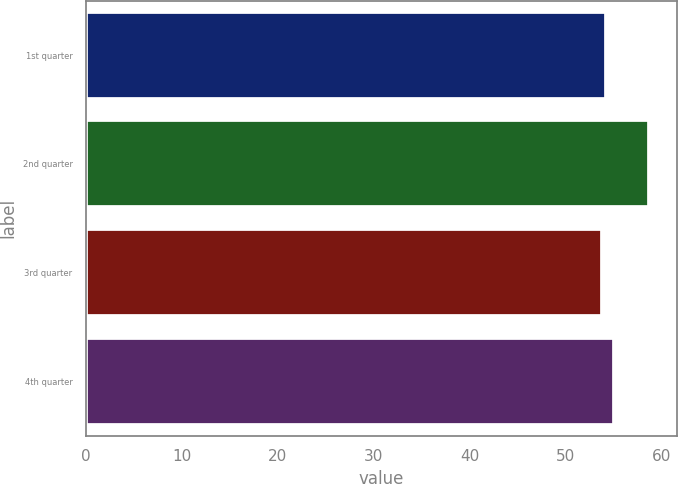Convert chart to OTSL. <chart><loc_0><loc_0><loc_500><loc_500><bar_chart><fcel>1st quarter<fcel>2nd quarter<fcel>3rd quarter<fcel>4th quarter<nl><fcel>54.25<fcel>58.66<fcel>53.76<fcel>55.03<nl></chart> 